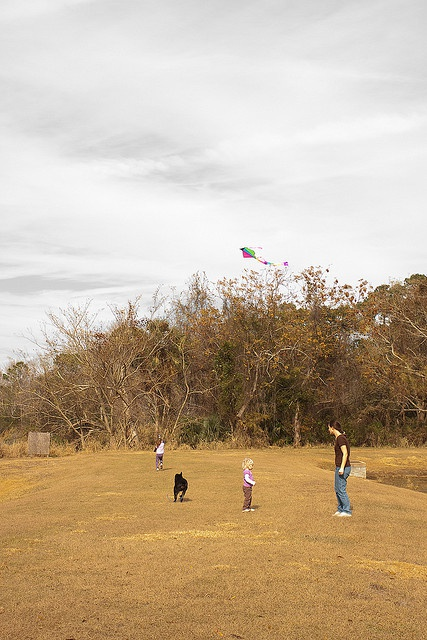Describe the objects in this image and their specific colors. I can see people in lightgray, maroon, gray, tan, and black tones, people in lightgray, brown, white, and tan tones, dog in lightgray, black, tan, and maroon tones, kite in lightgray, white, pink, violet, and magenta tones, and people in lightgray, gray, tan, and brown tones in this image. 